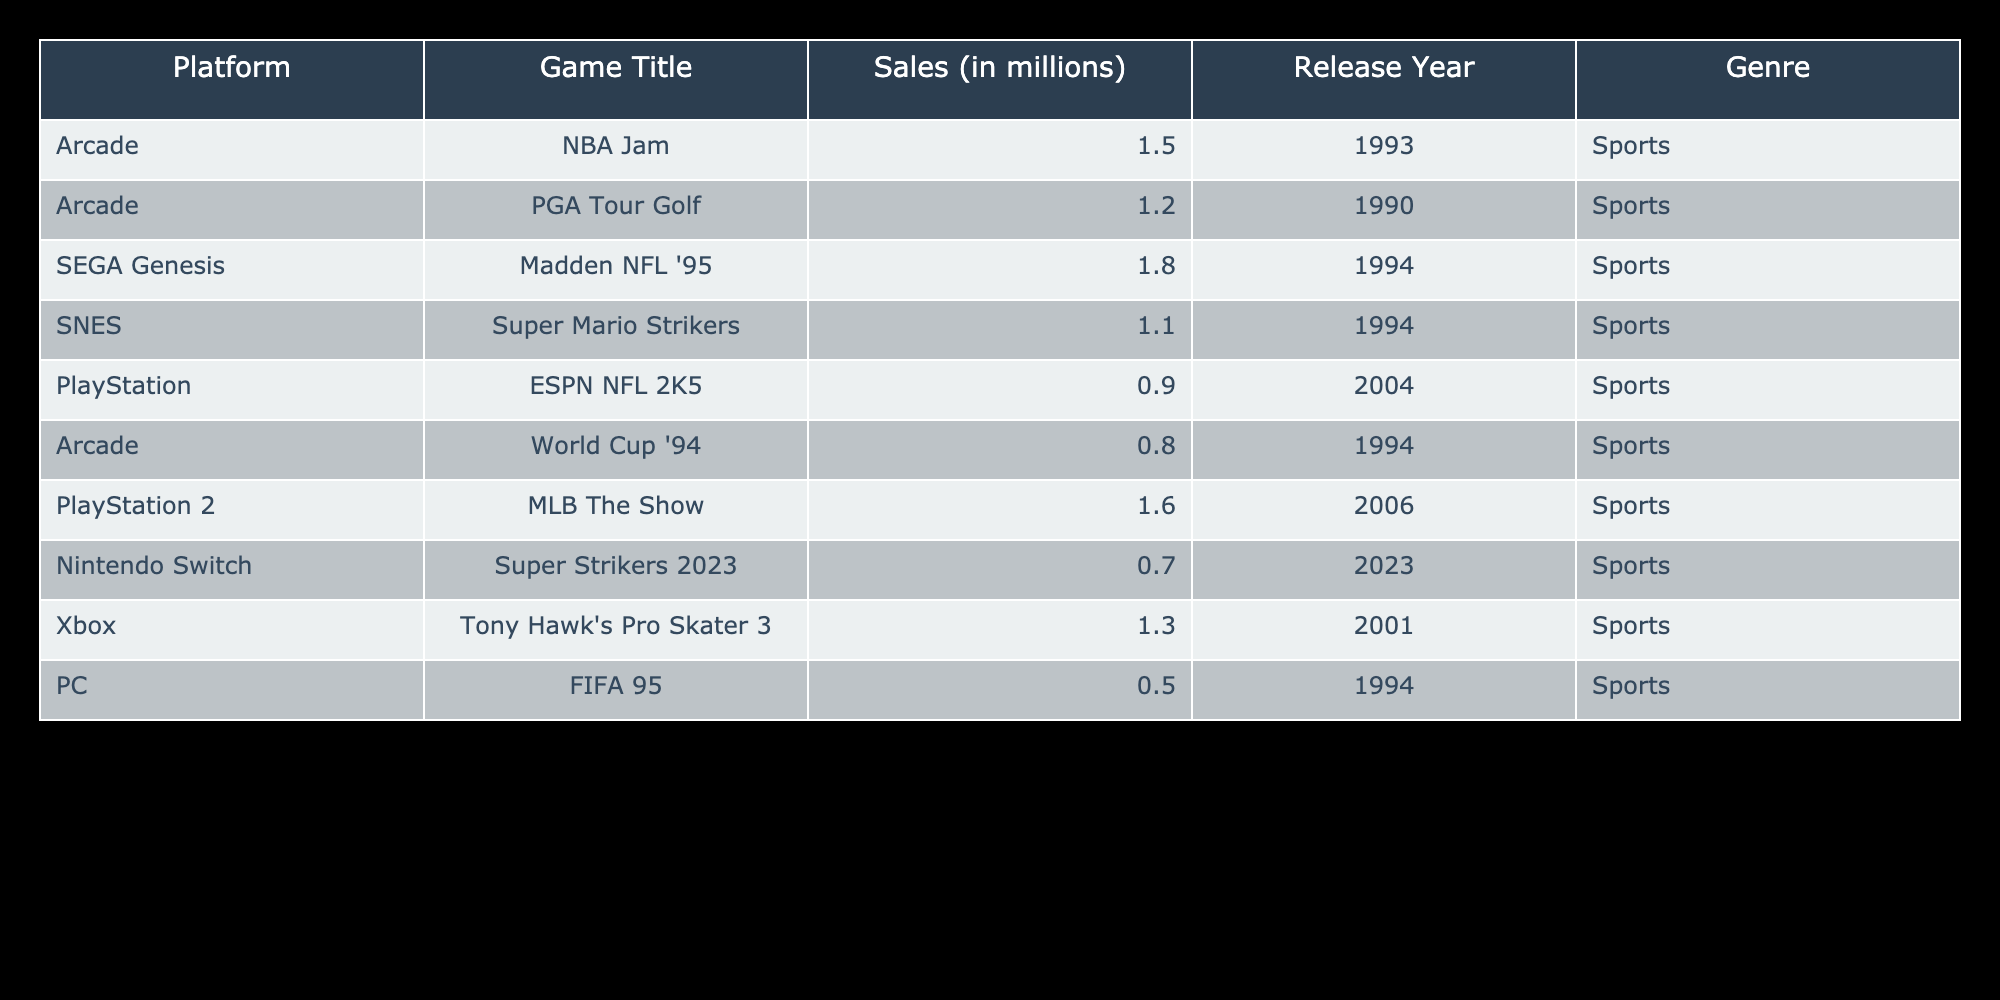What is the highest-selling classic arcade sports game? The highest-selling game can be found by inspecting the "Sales (in millions)" column in the table. "Madden NFL '95" on SEGA Genesis has the highest sales figure of 1.8 million.
Answer: Madden NFL '95 Which platform has the most titles listed in the table? By reviewing the platform column, there are multiple entries for "Arcade," which appears four times in the table, more than any other platform.
Answer: Arcade What is the total sales of sports games released before 2000? First, identify the games released before 2000 in the table: "NBA Jam," "PGA Tour Golf," "Madden NFL '95," "Super Mario Strikers," "World Cup '94," and "FIFA 95." Their sales are 1.5, 1.2, 1.8, 1.1, 0.8, and 0.5 million, respectively. Adding all these values together gives 1.5 + 1.2 + 1.8 + 1.1 + 0.8 + 0.5 = 7.9 million.
Answer: 7.9 million Is there a game on the Nintendo Switch in this table? Reviewing the "Platform" column, "Super Strikers 2023" is listed under Nintendo Switch, confirming that there is indeed a game on this platform.
Answer: Yes What is the average sales figure of all the games in the table? To find the average, sum up all the sales figures: 1.5 + 1.2 + 1.8 + 1.1 + 0.9 + 0.8 + 1.6 + 0.7 + 1.3 + 0.5 = 9.9 million. There are 10 games listed in the table, so the average is 9.9 / 10 = 0.99 million.
Answer: 0.99 million What is the difference between the sales of the highest and lowest-selling games? First, identify the highest-selling game, which is "Madden NFL '95" with sales of 1.8 million, and the lowest-selling game, which is "FIFA 95" with sales of 0.5 million. The difference is 1.8 - 0.5 = 1.3 million.
Answer: 1.3 million How many games sold more than 1 million copies? Check the sales figures against 1 million. The titles with sales greater than 1 million are: "Madden NFL '95," "NBA Jam," "MLB The Show," and "Tony Hawk's Pro Skater 3," totaling four games.
Answer: 4 Are there any games that have sales less than 1 million? By examining the sales figures, "ESPN NFL 2K5," "World Cup '94," and "FIFA 95" each have sales below 1 million, confirming there are games with sales less than this threshold.
Answer: Yes 